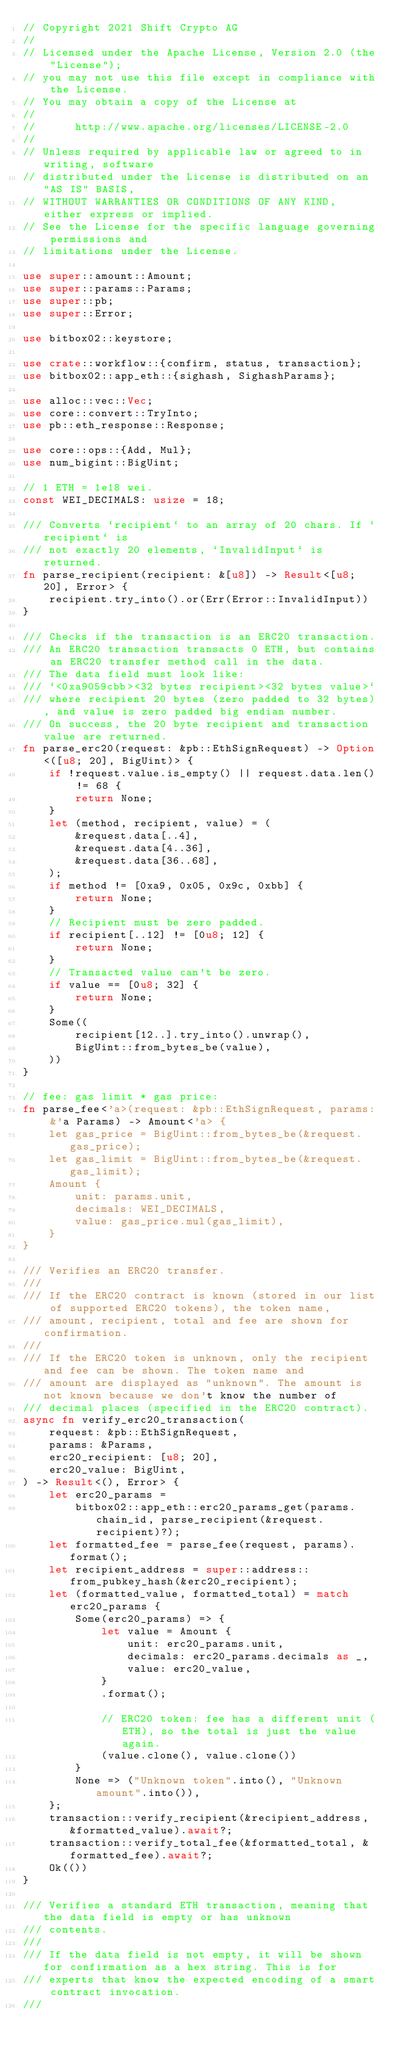Convert code to text. <code><loc_0><loc_0><loc_500><loc_500><_Rust_>// Copyright 2021 Shift Crypto AG
//
// Licensed under the Apache License, Version 2.0 (the "License");
// you may not use this file except in compliance with the License.
// You may obtain a copy of the License at
//
//      http://www.apache.org/licenses/LICENSE-2.0
//
// Unless required by applicable law or agreed to in writing, software
// distributed under the License is distributed on an "AS IS" BASIS,
// WITHOUT WARRANTIES OR CONDITIONS OF ANY KIND, either express or implied.
// See the License for the specific language governing permissions and
// limitations under the License.

use super::amount::Amount;
use super::params::Params;
use super::pb;
use super::Error;

use bitbox02::keystore;

use crate::workflow::{confirm, status, transaction};
use bitbox02::app_eth::{sighash, SighashParams};

use alloc::vec::Vec;
use core::convert::TryInto;
use pb::eth_response::Response;

use core::ops::{Add, Mul};
use num_bigint::BigUint;

// 1 ETH = 1e18 wei.
const WEI_DECIMALS: usize = 18;

/// Converts `recipient` to an array of 20 chars. If `recipient` is
/// not exactly 20 elements, `InvalidInput` is returned.
fn parse_recipient(recipient: &[u8]) -> Result<[u8; 20], Error> {
    recipient.try_into().or(Err(Error::InvalidInput))
}

/// Checks if the transaction is an ERC20 transaction.
/// An ERC20 transaction transacts 0 ETH, but contains an ERC20 transfer method call in the data.
/// The data field must look like:
/// `<0xa9059cbb><32 bytes recipient><32 bytes value>`
/// where recipient 20 bytes (zero padded to 32 bytes), and value is zero padded big endian number.
/// On success, the 20 byte recipient and transaction value are returned.
fn parse_erc20(request: &pb::EthSignRequest) -> Option<([u8; 20], BigUint)> {
    if !request.value.is_empty() || request.data.len() != 68 {
        return None;
    }
    let (method, recipient, value) = (
        &request.data[..4],
        &request.data[4..36],
        &request.data[36..68],
    );
    if method != [0xa9, 0x05, 0x9c, 0xbb] {
        return None;
    }
    // Recipient must be zero padded.
    if recipient[..12] != [0u8; 12] {
        return None;
    }
    // Transacted value can't be zero.
    if value == [0u8; 32] {
        return None;
    }
    Some((
        recipient[12..].try_into().unwrap(),
        BigUint::from_bytes_be(value),
    ))
}

// fee: gas limit * gas price:
fn parse_fee<'a>(request: &pb::EthSignRequest, params: &'a Params) -> Amount<'a> {
    let gas_price = BigUint::from_bytes_be(&request.gas_price);
    let gas_limit = BigUint::from_bytes_be(&request.gas_limit);
    Amount {
        unit: params.unit,
        decimals: WEI_DECIMALS,
        value: gas_price.mul(gas_limit),
    }
}

/// Verifies an ERC20 transfer.
///
/// If the ERC20 contract is known (stored in our list of supported ERC20 tokens), the token name,
/// amount, recipient, total and fee are shown for confirmation.
///
/// If the ERC20 token is unknown, only the recipient and fee can be shown. The token name and
/// amount are displayed as "unknown". The amount is not known because we don't know the number of
/// decimal places (specified in the ERC20 contract).
async fn verify_erc20_transaction(
    request: &pb::EthSignRequest,
    params: &Params,
    erc20_recipient: [u8; 20],
    erc20_value: BigUint,
) -> Result<(), Error> {
    let erc20_params =
        bitbox02::app_eth::erc20_params_get(params.chain_id, parse_recipient(&request.recipient)?);
    let formatted_fee = parse_fee(request, params).format();
    let recipient_address = super::address::from_pubkey_hash(&erc20_recipient);
    let (formatted_value, formatted_total) = match erc20_params {
        Some(erc20_params) => {
            let value = Amount {
                unit: erc20_params.unit,
                decimals: erc20_params.decimals as _,
                value: erc20_value,
            }
            .format();

            // ERC20 token: fee has a different unit (ETH), so the total is just the value again.
            (value.clone(), value.clone())
        }
        None => ("Unknown token".into(), "Unknown amount".into()),
    };
    transaction::verify_recipient(&recipient_address, &formatted_value).await?;
    transaction::verify_total_fee(&formatted_total, &formatted_fee).await?;
    Ok(())
}

/// Verifies a standard ETH transaction, meaning that the data field is empty or has unknown
/// contents.
///
/// If the data field is not empty, it will be shown for confirmation as a hex string. This is for
/// experts that know the expected encoding of a smart contract invocation.
///</code> 